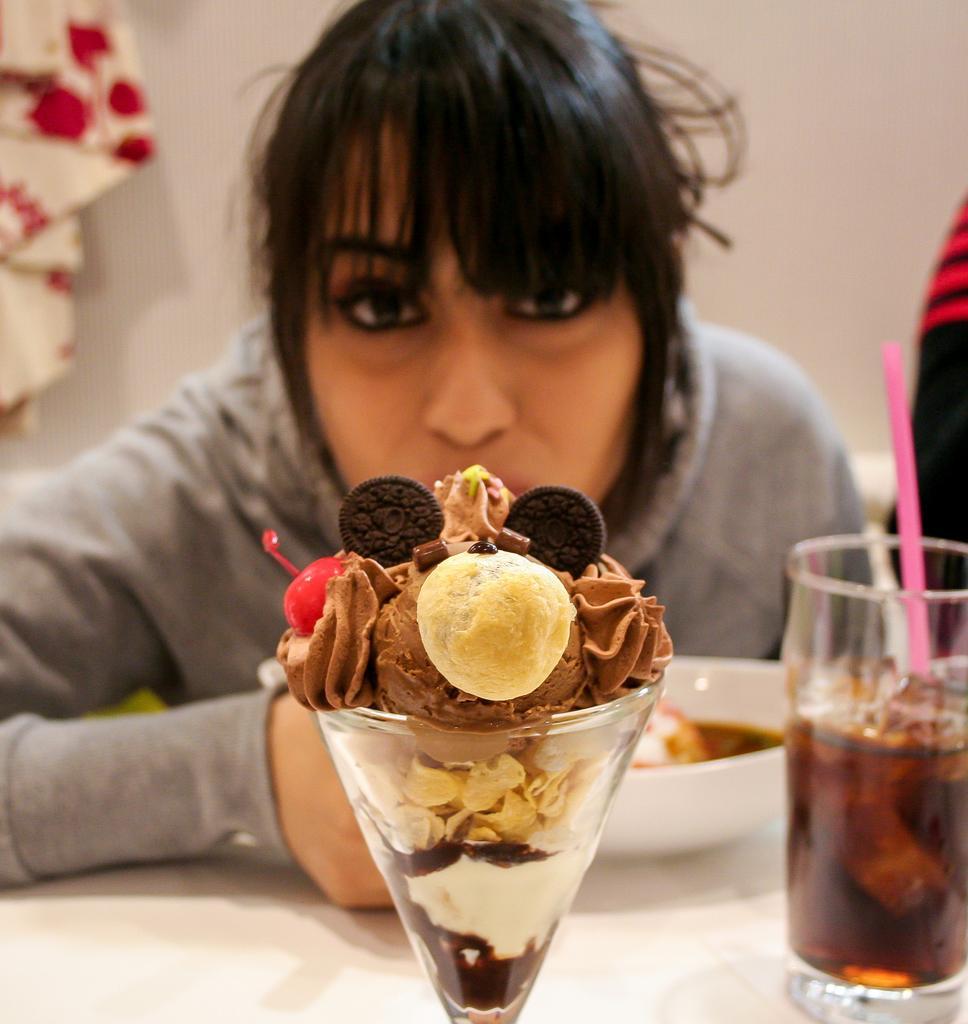Describe this image in one or two sentences. In this image, we can see a person. We can see a table with some objects like a few glasses. We can see the wall. We can also see an object on the right. We can also see an object on the top left. 